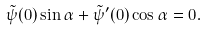<formula> <loc_0><loc_0><loc_500><loc_500>\tilde { \psi } ( 0 ) \sin \alpha + \tilde { \psi } ^ { \prime } ( 0 ) \cos \alpha = 0 .</formula> 